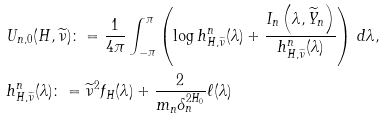Convert formula to latex. <formula><loc_0><loc_0><loc_500><loc_500>& U _ { n , 0 } ( H , \widetilde { \nu } ) \colon = \frac { 1 } { 4 \pi } \int _ { - \pi } ^ { \pi } \left ( \log { h _ { H , \widetilde { \nu } } ^ { n } ( \lambda ) } + \frac { I _ { n } \left ( \lambda , \widetilde { Y } _ { n } \right ) } { h _ { H , \widetilde { \nu } } ^ { n } ( \lambda ) } \right ) \, d \lambda , \\ & h _ { H , \widetilde { \nu } } ^ { n } ( \lambda ) \colon = \widetilde { \nu } ^ { 2 } f _ { H } ( \lambda ) + \frac { 2 } { m _ { n } \delta _ { n } ^ { 2 H _ { 0 } } } \ell ( \lambda )</formula> 